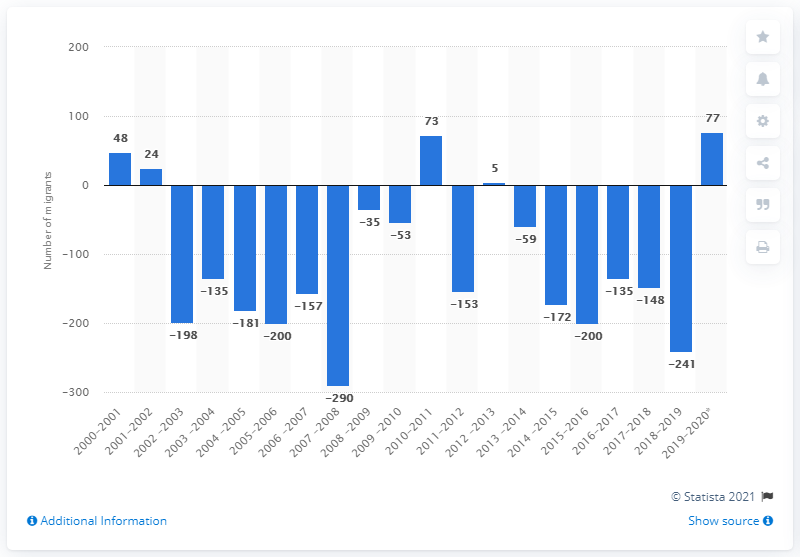Give some essential details in this illustration. During the period of July 1, 2019, to June 30, 2020, more people moved to Nunavut from other provinces than left Nunavut, a difference of 77 people. 